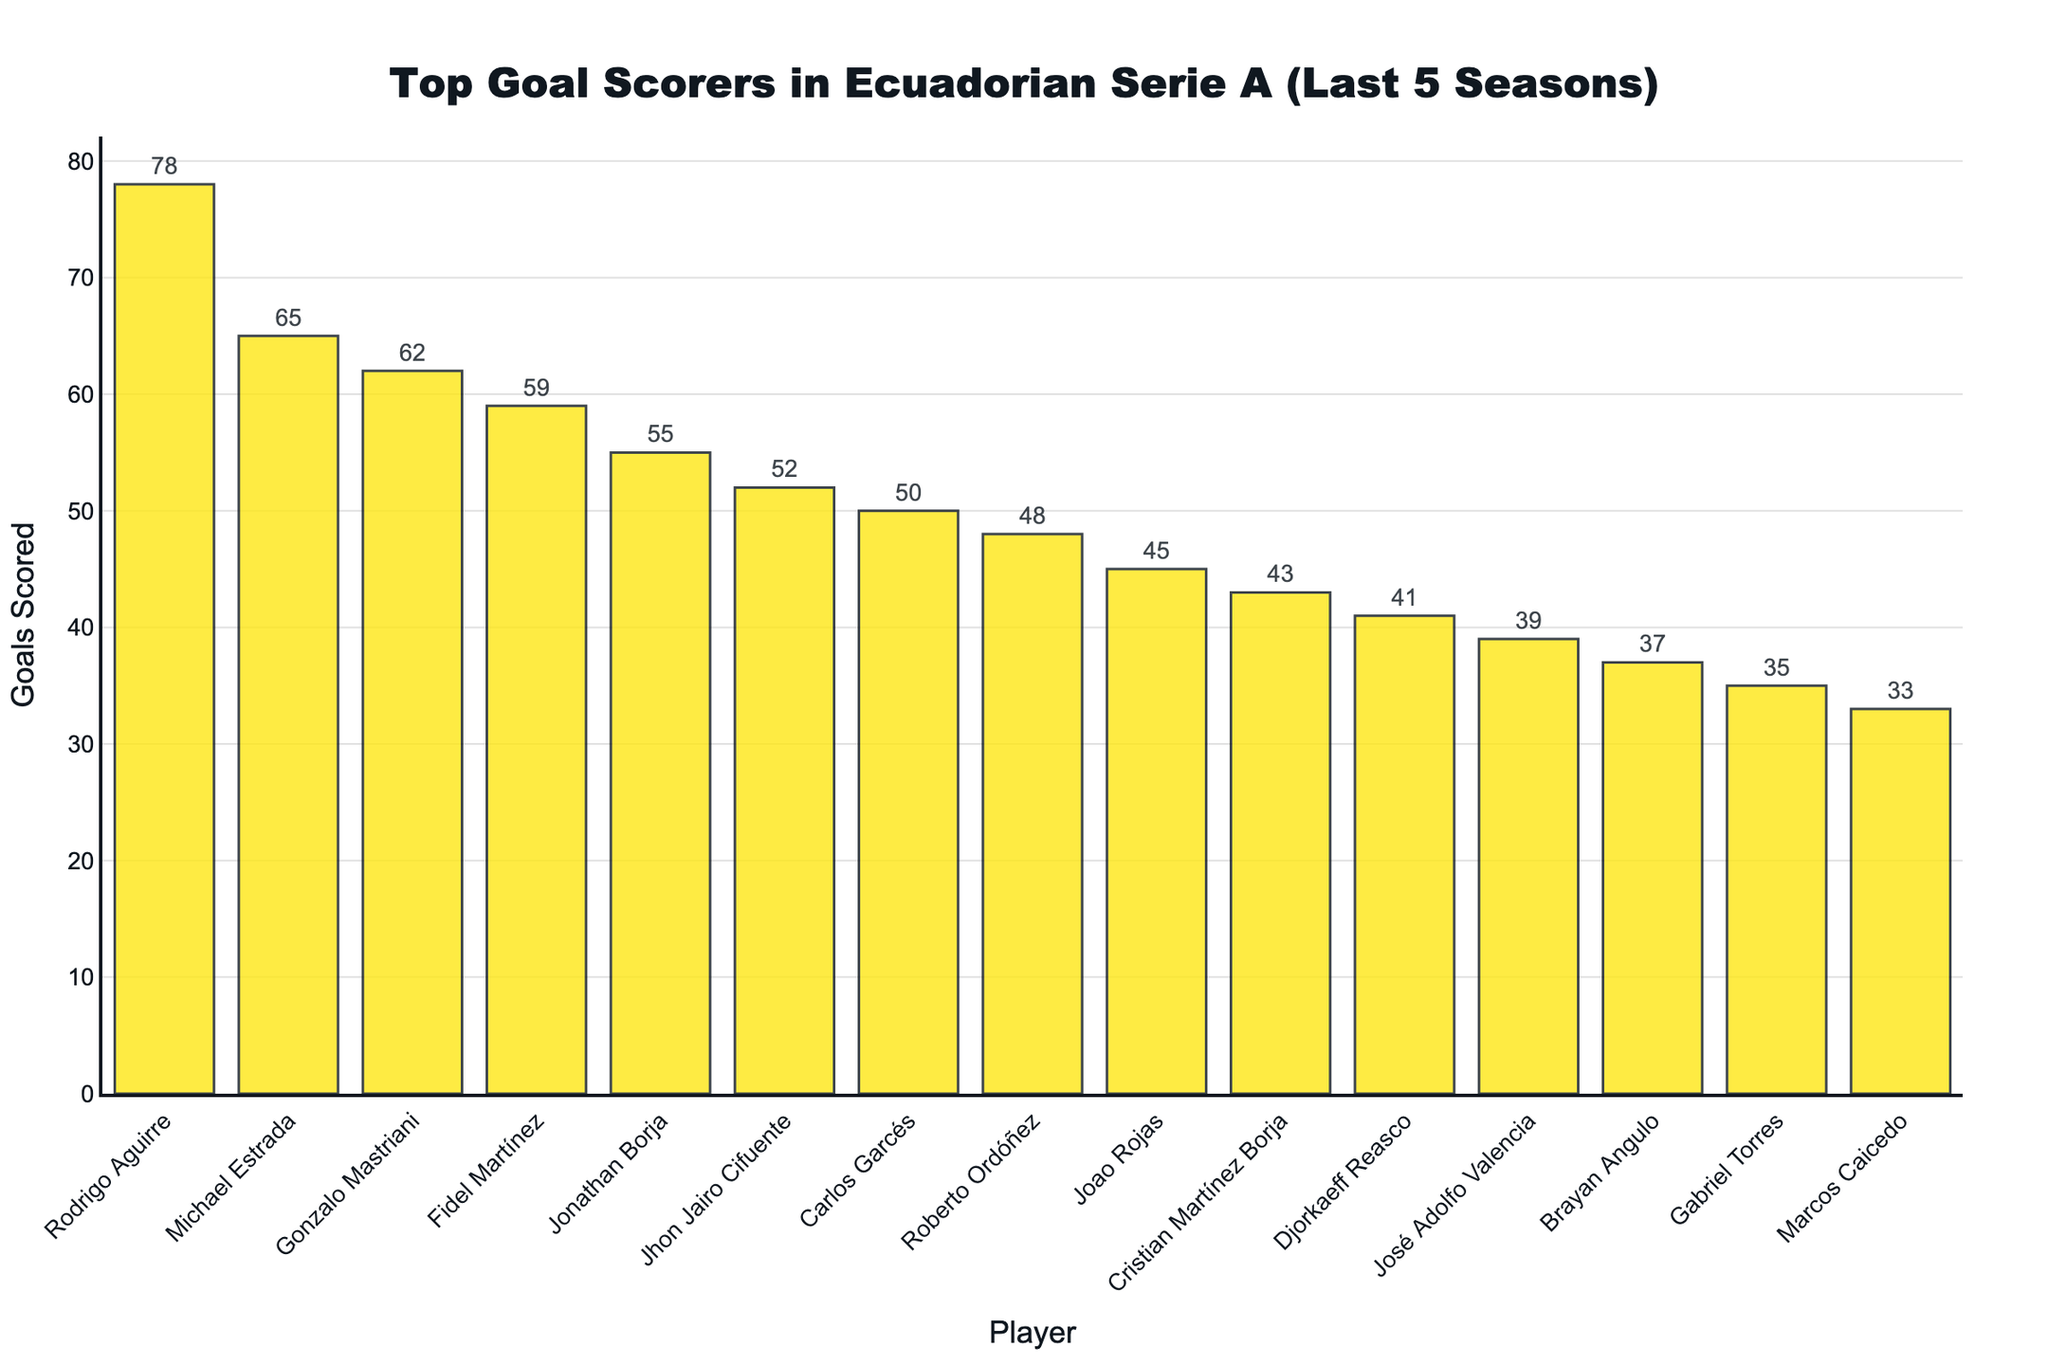How many more goals did Rodrigo Aguirre score compared to Michael Estrada? First, find the goals scored by Rodrigo Aguirre (78) and Michael Estrada (65). Subtract the number of goals scored by Michael Estrada from Rodrigo Aguirre: 78 - 65 = 13.
Answer: 13 Which player scored the second most goals? Look at the bar with the second highest height after Rodrigo Aguirre, which represents Michael Estrada with 65 goals.
Answer: Michael Estrada What is the total number of goals scored by the top 3 goal scorers? Sum the goals of the top 3 players: Rodrigo Aguirre (78) + Michael Estrada (65) + Gonzalo Mastriani (62). The sum is 78 + 65 + 62 = 205.
Answer: 205 Who scored the least goals among the top 15 players? Identify the player represented by the shortest bar, which is Marcos Caicedo with 33 goals.
Answer: Marcos Caicedo What is the average number of goals scored by the players who scored over 50 goals? There are 6 players who scored over 50 goals. Sum their goals: Rodrigo Aguirre (78) + Michael Estrada (65) + Gonzalo Mastriani (62) + Fidel Martínez (59) + Jonathan Borja (55) + Jhon Jairo Cifuente (52) = 371. Then, divide by the number of players: 371 / 6 ≈ 61.83.
Answer: 61.83 How many players scored between 40 and 50 goals? Count the bars representing players with goals between 40 and 50: Djorkaeff Reasco (41), José Adolfo Valencia (39), Brayan Angulo (37), and Roberto Ordóñez (48). This gives us 4 players.
Answer: 4 Identify the player who scored exactly 45 goals. Find the bar labeled with 45 goals, which represents Joao Rojas.
Answer: Joao Rojas By how much does the total number of goals scored by the bottom 5 players exceed 175? Sum the goals of the bottom 5 players: Djorkaeff Reasco (41) + José Adolfo Valencia (39) + Brayan Angulo (37) + Gabriel Torres (35) + Marcos Caicedo (33) = 185. Subtract 175 from this sum: 185 - 175 = 10.
Answer: 10 What is the difference in goals between the player with the highest goals and the player with the lowest goals? Find the goals of Rodrigo Aguirre (highest, 78) and Marcos Caicedo (lowest, 33). Subtract the latter from the former: 78 - 33 = 45.
Answer: 45 